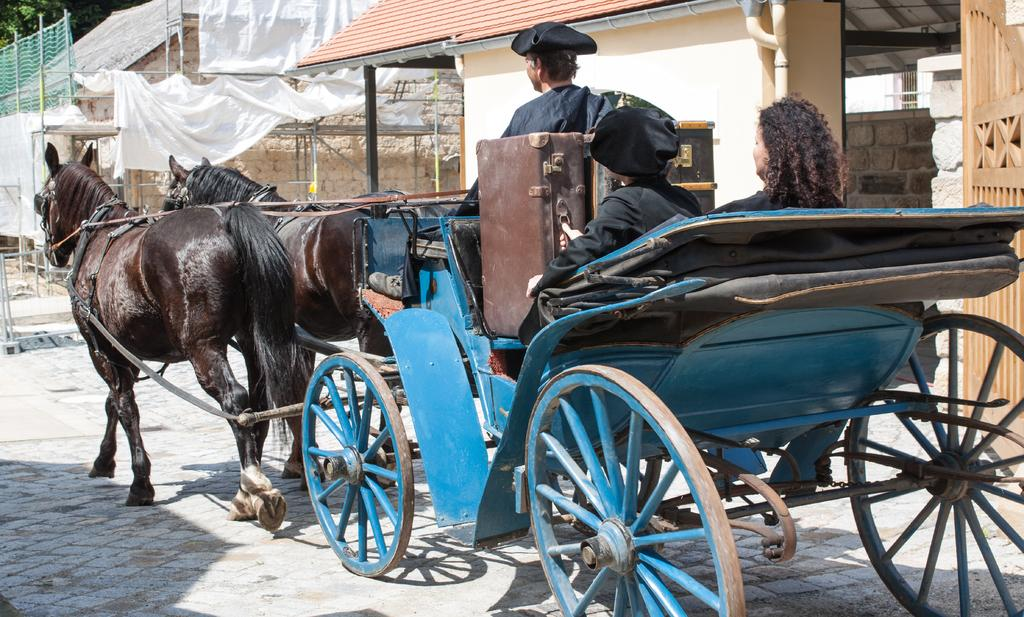What is the main subject in the foreground of the image? There is a horse cart in the foreground of the image. Who or what is on the horse cart? Persons are on the horse cart. What else is on the horse cart besides the persons? Suitcases are on the horse cart. What can be seen in the background of the image? There are houses, a door, a wall, white clothes, and a tree in the background of the image. What type of fuel is being used by the jellyfish in the image? There are no jellyfish present in the image, so it is not possible to determine what type of fuel they might be using. 